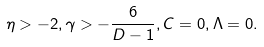<formula> <loc_0><loc_0><loc_500><loc_500>\eta > - 2 , \gamma > - \frac { 6 } { D - 1 } , C = 0 , \Lambda = 0 .</formula> 